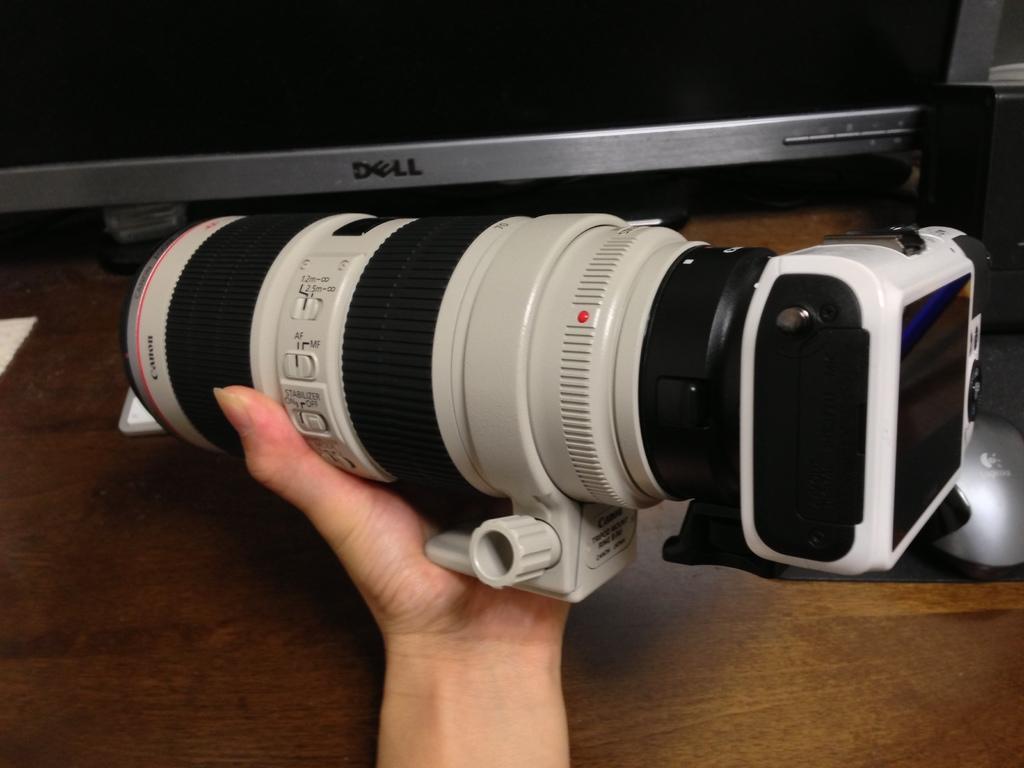In one or two sentences, can you explain what this image depicts? In the center of the image we can see a person's hand holding a camera, behind it there is a computer. At the bottom there is a table. 